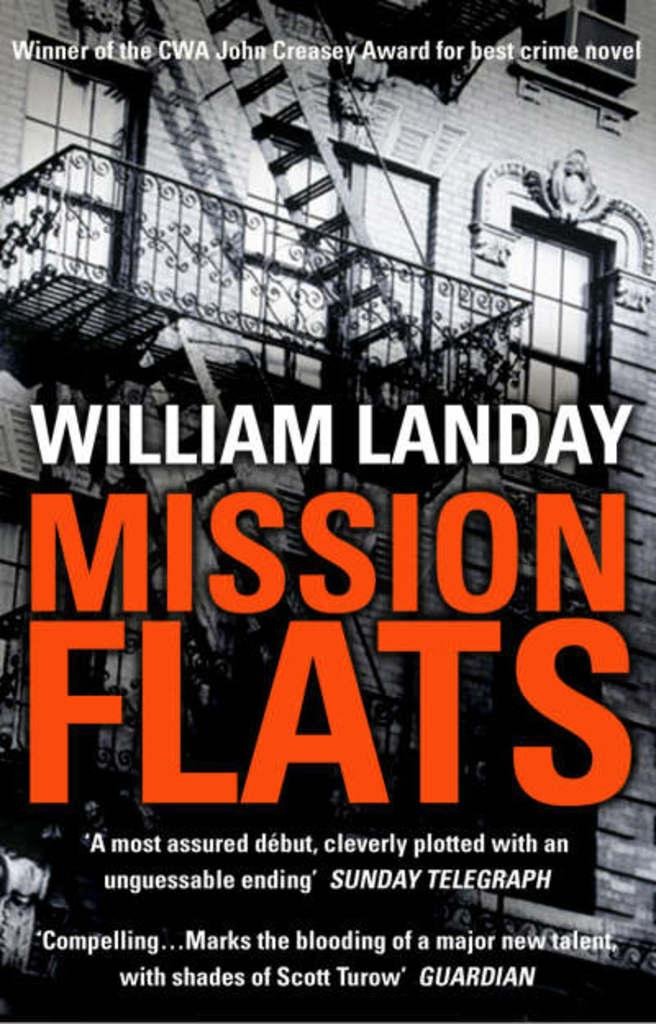<image>
Create a compact narrative representing the image presented. A book called Mission Flats from author William Landy showing and old building with an attached staircase outside on the front cover of the book. 